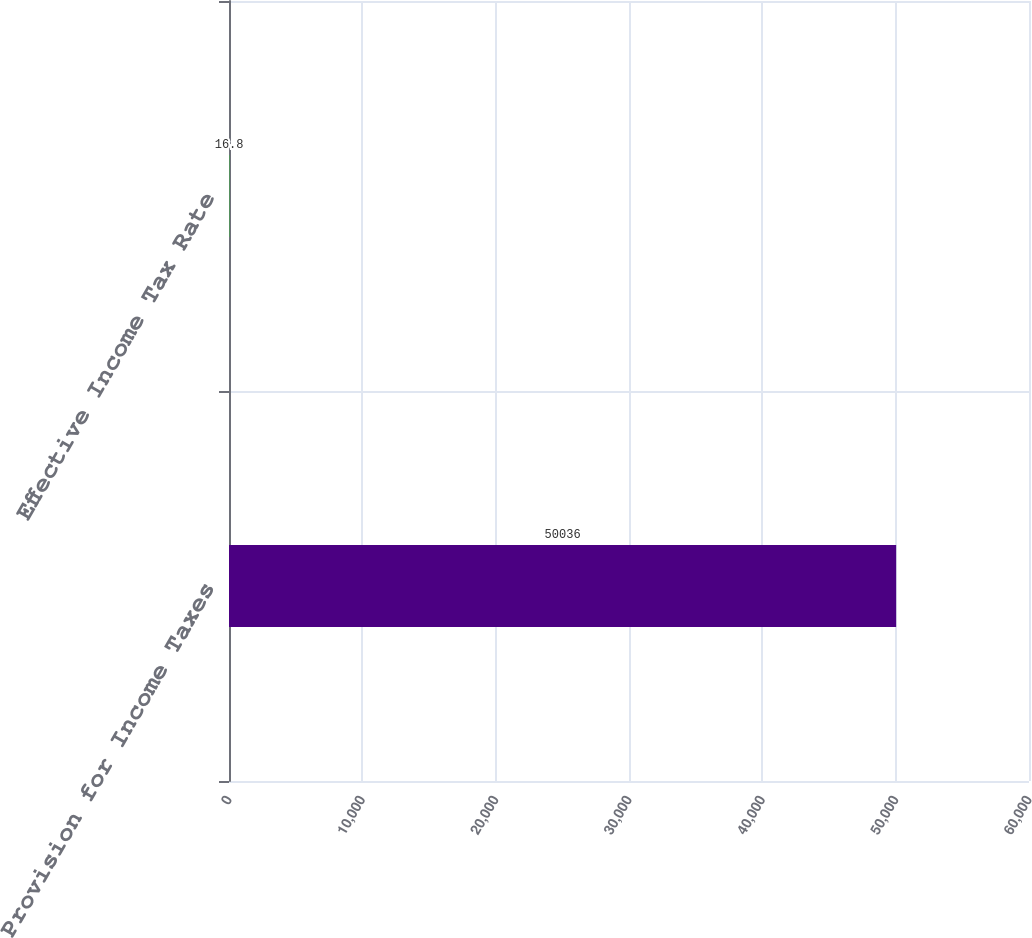<chart> <loc_0><loc_0><loc_500><loc_500><bar_chart><fcel>Provision for Income Taxes<fcel>Effective Income Tax Rate<nl><fcel>50036<fcel>16.8<nl></chart> 